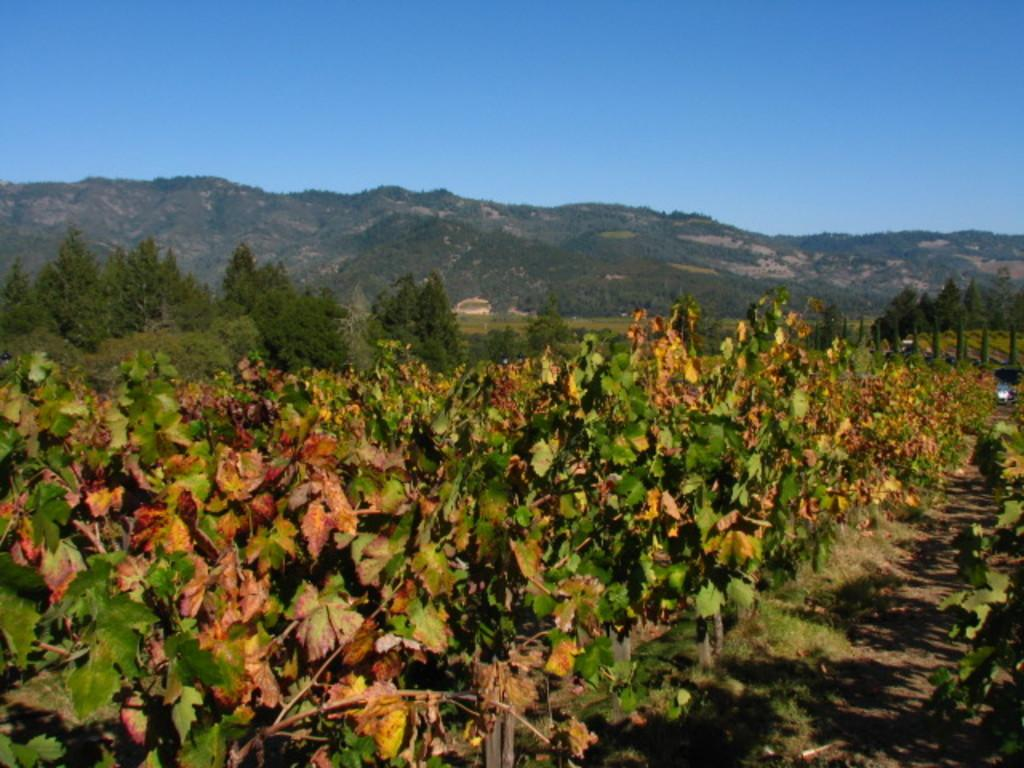What type of vegetation can be seen in the image? There are plants and trees in the image. What can be seen in the background of the image? Hills and a clear sky are visible in the background of the image. What type of quill is being used to write on the vessel in the image? There is no quill or vessel present in the image; it features plants, trees, hills, and a clear sky. 